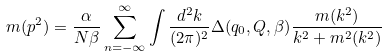<formula> <loc_0><loc_0><loc_500><loc_500>m ( p ^ { 2 } ) = \frac { \alpha } { N \beta } \sum ^ { \infty } _ { n = - \infty } \int \frac { d ^ { 2 } k } { ( 2 \pi ) ^ { 2 } } \Delta ( q _ { 0 } , Q , \beta ) \frac { m ( k ^ { 2 } ) } { k ^ { 2 } + m ^ { 2 } ( k ^ { 2 } ) }</formula> 